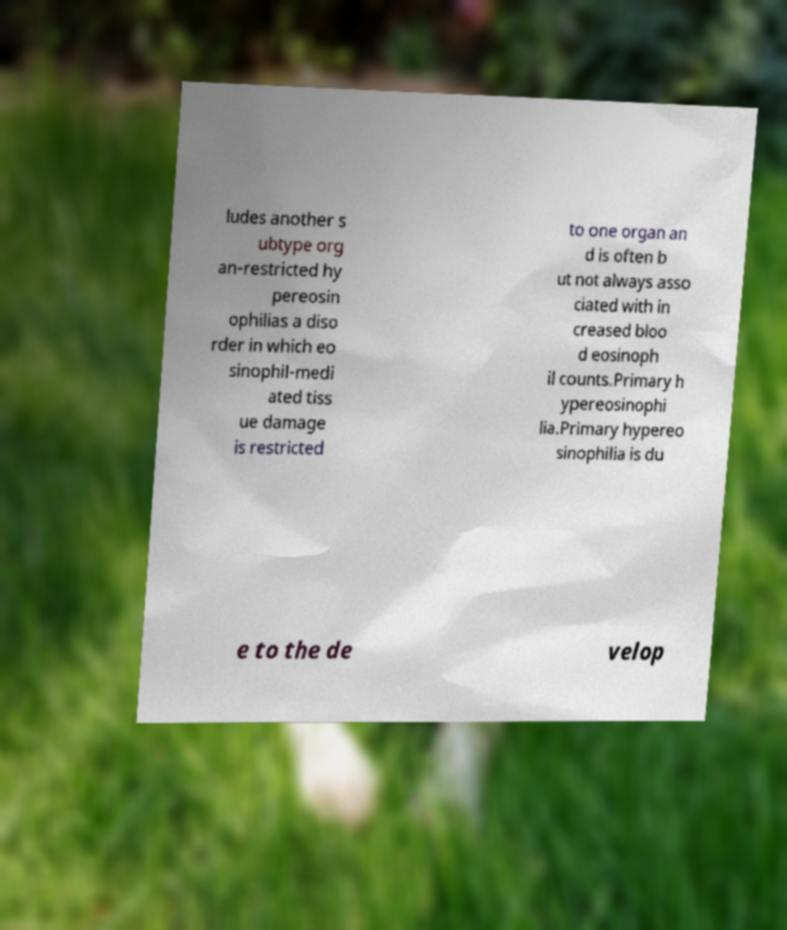Please read and relay the text visible in this image. What does it say? ludes another s ubtype org an-restricted hy pereosin ophilias a diso rder in which eo sinophil-medi ated tiss ue damage is restricted to one organ an d is often b ut not always asso ciated with in creased bloo d eosinoph il counts.Primary h ypereosinophi lia.Primary hypereo sinophilia is du e to the de velop 